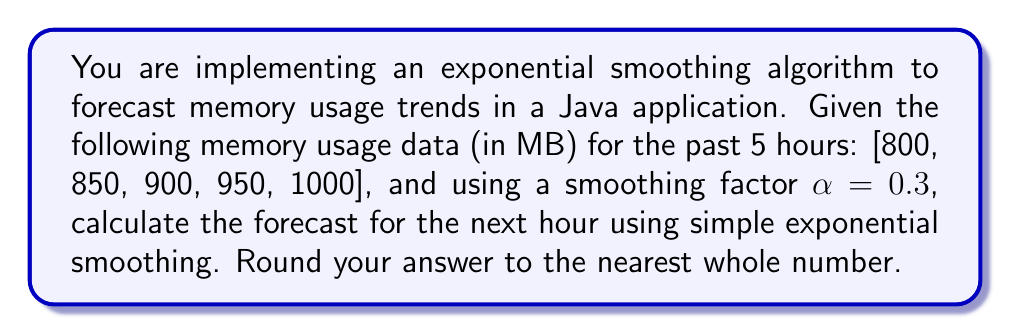Can you solve this math problem? To solve this problem, we'll use the simple exponential smoothing formula:

$$F_{t+1} = \alpha Y_t + (1-\alpha)F_t$$

Where:
$F_{t+1}$ is the forecast for the next period
$\alpha$ is the smoothing factor (0.3 in this case)
$Y_t$ is the actual value at time t
$F_t$ is the forecast for the current period

We'll start by initializing $F_1$ with the first observed value:

$F_1 = 800$

Now, let's calculate the forecasts for each period:

For t = 1:
$$F_2 = 0.3 \cdot 850 + (1-0.3) \cdot 800 = 255 + 560 = 815$$

For t = 2:
$$F_3 = 0.3 \cdot 900 + (1-0.3) \cdot 815 = 270 + 570.5 = 840.5$$

For t = 3:
$$F_4 = 0.3 \cdot 950 + (1-0.3) \cdot 840.5 = 285 + 588.35 = 873.35$$

For t = 4:
$$F_5 = 0.3 \cdot 1000 + (1-0.3) \cdot 873.35 = 300 + 611.345 = 911.345$$

Finally, for t = 5 (which gives us the forecast for the next hour):
$$F_6 = 0.3 \cdot 1000 + (1-0.3) \cdot 911.345 = 300 + 637.9415 = 937.9415$$

Rounding to the nearest whole number: 938 MB
Answer: 938 MB 